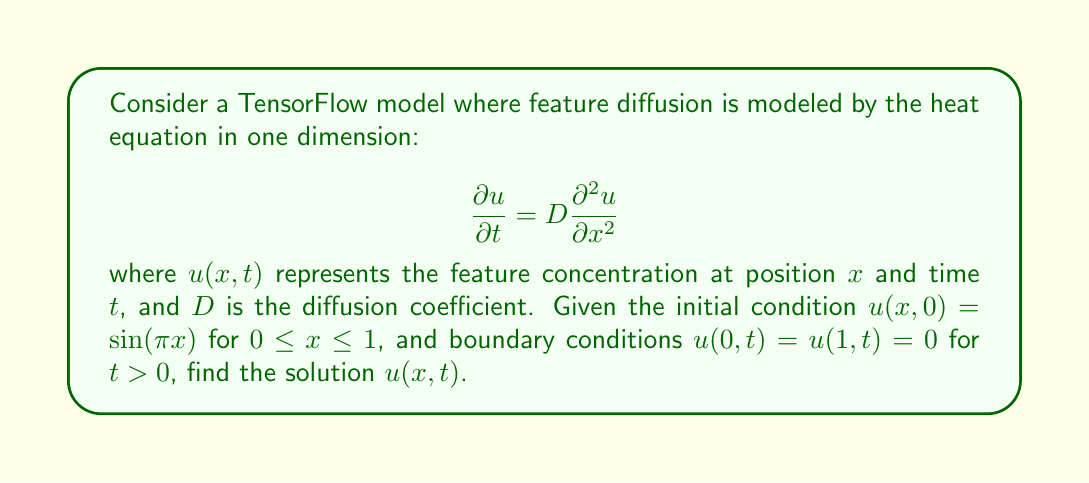What is the answer to this math problem? To solve this partial differential equation (PDE), we'll use the method of separation of variables.

1) Assume the solution has the form: $u(x,t) = X(x)T(t)$

2) Substitute this into the PDE:
   $$X(x)\frac{dT}{dt} = DT(t)\frac{d^2X}{dx^2}$$

3) Divide both sides by $DX(x)T(t)$:
   $$\frac{1}{DT}\frac{dT}{dt} = \frac{1}{X}\frac{d^2X}{dx^2}$$

4) Since the left side depends only on $t$ and the right side only on $x$, both must equal a constant, say $-\lambda^2$:
   $$\frac{1}{DT}\frac{dT}{dt} = -\lambda^2 \quad \text{and} \quad \frac{1}{X}\frac{d^2X}{dx^2} = -\lambda^2$$

5) Solve the $X$ equation:
   $$\frac{d^2X}{dx^2} + \lambda^2X = 0$$
   General solution: $X(x) = A\sin(\lambda x) + B\cos(\lambda x)$

6) Apply boundary conditions:
   $X(0) = 0 \implies B = 0$
   $X(1) = 0 \implies A\sin(\lambda) = 0$
   For non-trivial solutions, $\lambda = n\pi$ where $n$ is a positive integer.

7) Solve the $T$ equation:
   $$\frac{dT}{dt} = -D\lambda^2T$$
   Solution: $T(t) = Ce^{-D\lambda^2t} = Ce^{-Dn^2\pi^2t}$

8) The general solution is:
   $$u(x,t) = \sum_{n=1}^{\infty} C_n \sin(n\pi x)e^{-Dn^2\pi^2t}$$

9) Apply the initial condition to find $C_n$:
   $$\sin(\pi x) = \sum_{n=1}^{\infty} C_n \sin(n\pi x)$$
   This is satisfied when $C_1 = 1$ and $C_n = 0$ for $n > 1$

Therefore, the final solution is:
$$u(x,t) = \sin(\pi x)e^{-D\pi^2t}$$
Answer: $$u(x,t) = \sin(\pi x)e^{-D\pi^2t}$$ 